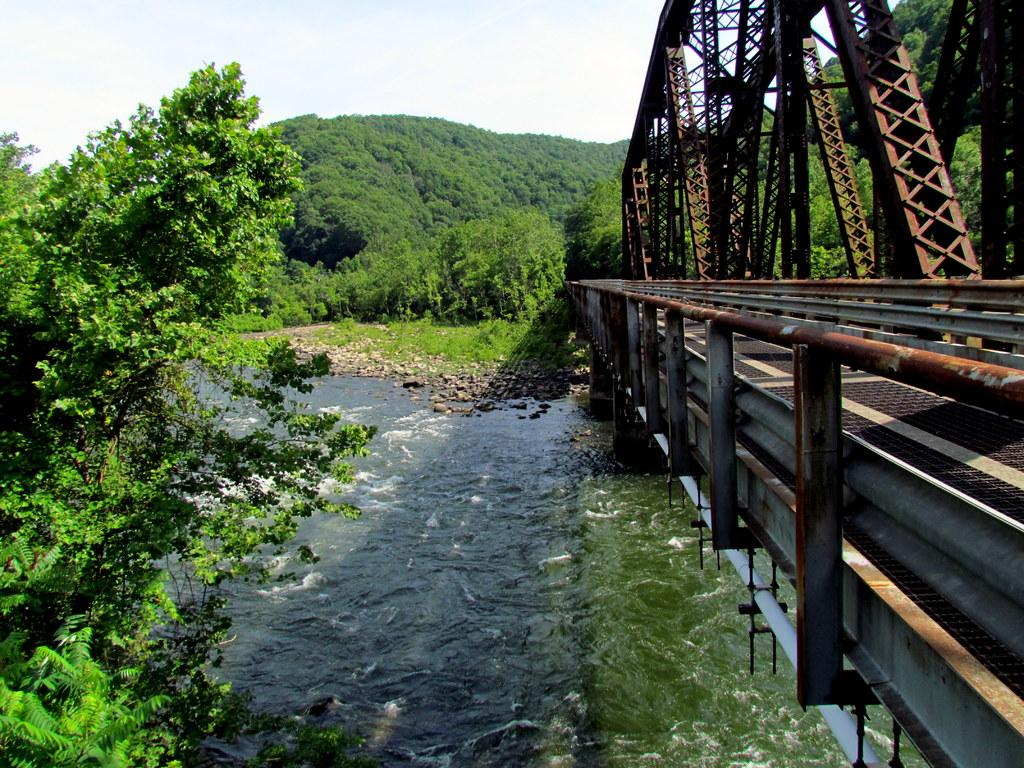What structure can be seen in the image? There is a bridge in the image. What is located beneath the bridge? There is a river below the bridge. What type of vegetation is present near the river? There are many trees around the river. What type of approval is required to cross the bridge in the image? There is no information about any approval required to cross the bridge in the image. 